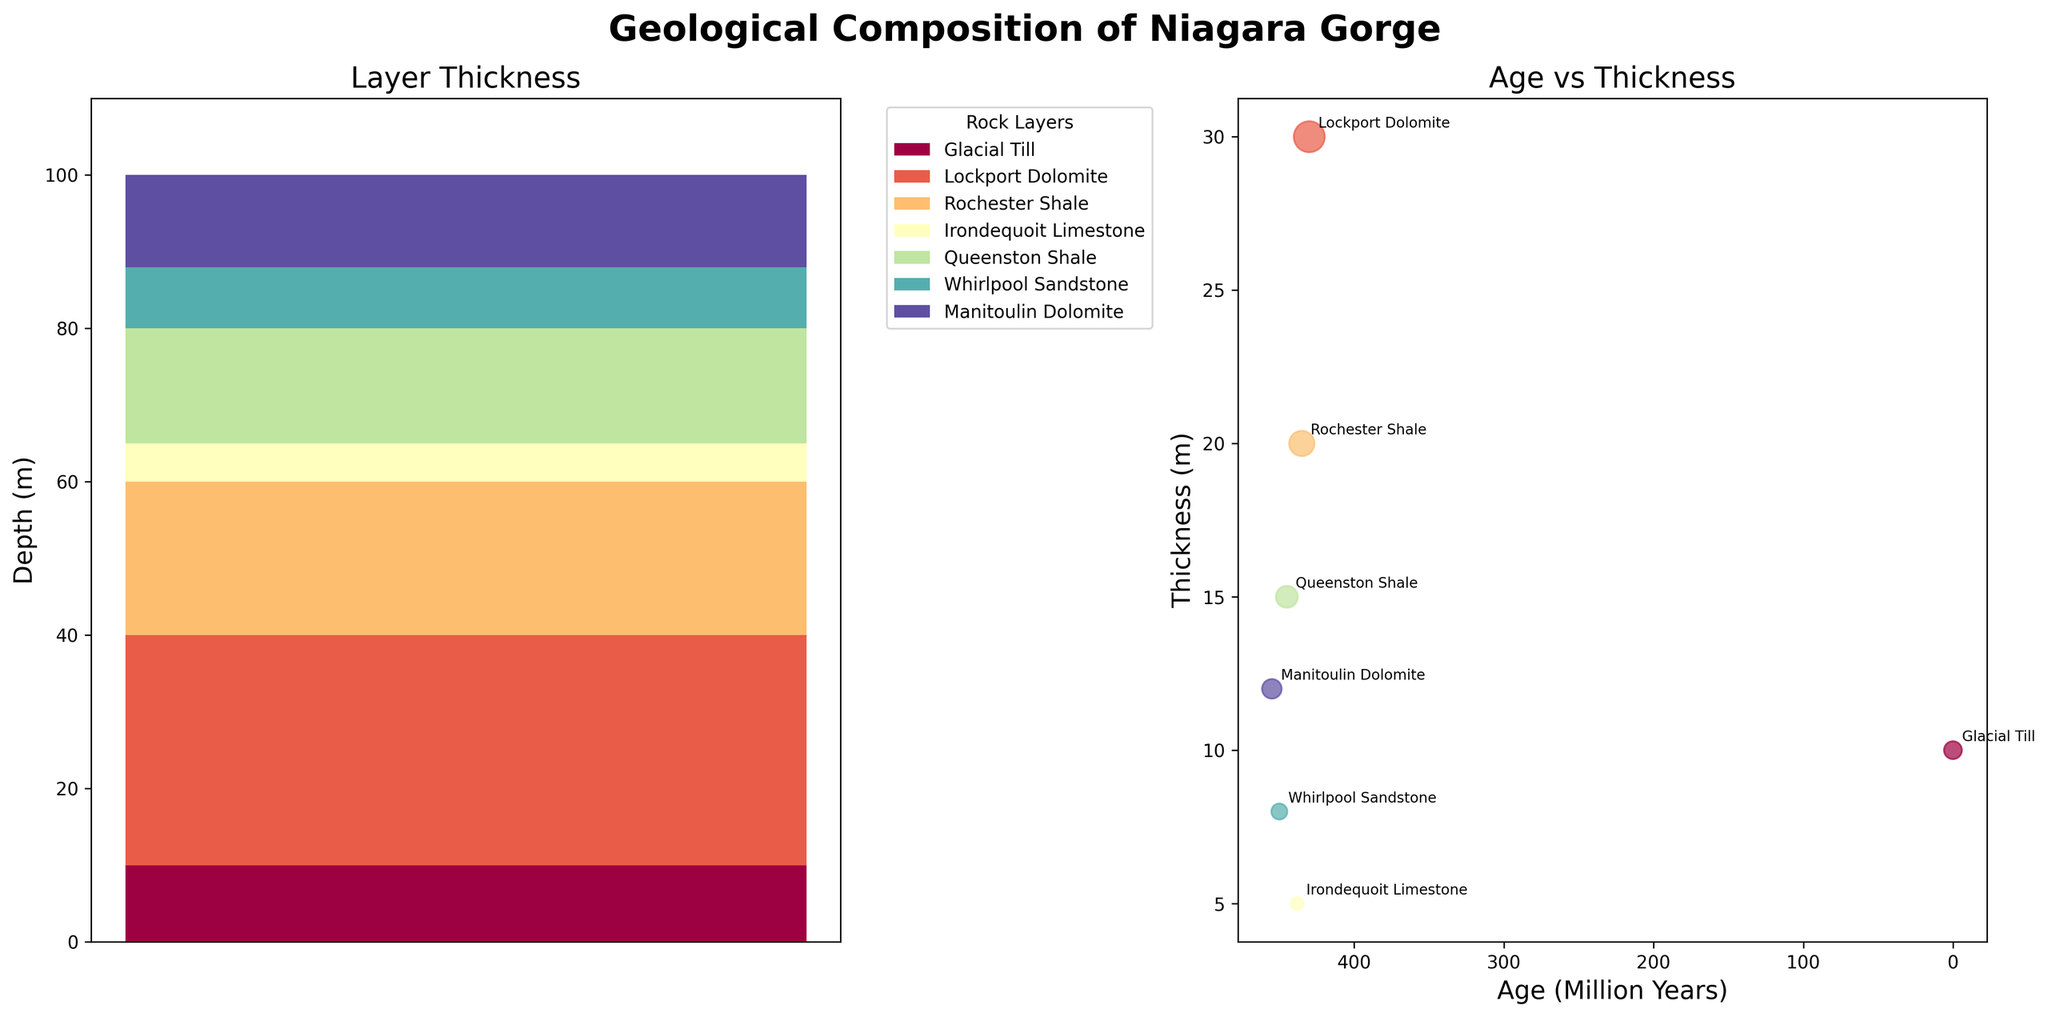what is the title of the figure? The title of the figure is located at the top center of the figure. It reads "Geological Composition of Niagara Gorge".
Answer: Geological Composition of Niagara Gorge What is the thickness of the Lockport Dolomite layer? In the "Layer Thickness" subplot, the Lockport Dolomite's thickness can be identified by looking for its color in the stacked bar. According to the legend, locate the bar's segment corresponding to Lockport Dolomite.
Answer: 30 meters How are the ages of the geological layers represented in the scatter plot? In the "Age vs Thickness" subplot, the ages of the geological layers are shown on the x-axis. The y-axis represents the thickness of each layer. Each stone's age roughly appears as the annotation near each scatter point starting from the left (oldest) to right (youngest).
Answer: x-axis Which geological layer has the smallest thickness, and how thick is it? In the "Layer Thickness" subplot, the thinnest segment can be observed in the stacked bar. Alternatively, in the "Age vs Thickness" scatter plot, the smallest circle corresponds to the smallest thickness. According to the legend and annotations, this layer is the Irondequoit Limestone.
Answer: Irondequoit Limestone, 5 meters What is the approximate age in million years of the Whirlpool Sandstone layer? Examine the "Age vs Thickness" scatter plot and find the point annotated with "Whirlpool Sandstone." Check the x-axis to determine its approximate age in million years.
Answer: 450 million years What is the total thickness of the layers from the Silurian period? In the "Layer Thickness" subplot, sum the thicknesses of all the bars labeled as Silurian from the legend, specifically: Lockport Dolomite (30m), Rochester Shale (20m), and Irondequoit Limestone (5m). The total is 30 + 20 + 5 = 55 meters.
Answer: 55 meters Which two layers have the greatest age difference, and what is their age difference? Look at the annotations on the "Age vs Thickness" scatter plot and identify the ages of the layers. The oldest is Manitoulin Dolomite (455 million years), and the youngest is Glacial Till (0.01 million years). The age difference is 455 - 0.01 ≈ 454.99 million years.
Answer: Manitoulin Dolomite and Glacial Till, 454.99 million years Which sedimentary layer is the thickest? In the "Layer Thickness" subplot, observe the height of each segment in the stacked bar. According to the legend, the thickest sedimentary segment is the Lockport Dolomite at 30 meters.
Answer: Lockport Dolomite How does the thickness of the Rochester Shale compare to the Queenston Shale? Find the segments for both Rochester Shale and Queenston Shale in the stacked bar within the "Layer Thickness" subplot or look for their points in the "Age vs Thickness" scatter plot. Rochester Shale is 20 meters, and Queenston Shale is 15 meters. Rochester Shale is thicker.
Answer: Rochester Shale is thicker by 5 meters Why is the x-axis in the scatter plot inverted, and what advantage does this provide? The x-axis in the "Age vs Thickness" scatter plot is inverted so the oldest layers appear on the left and the younger layers appear on the right, which often aligns with common geological timelines presented in this way, providing a logical visual flow from oldest to youngest.
Answer: To align geological timelines from oldest to youngest 